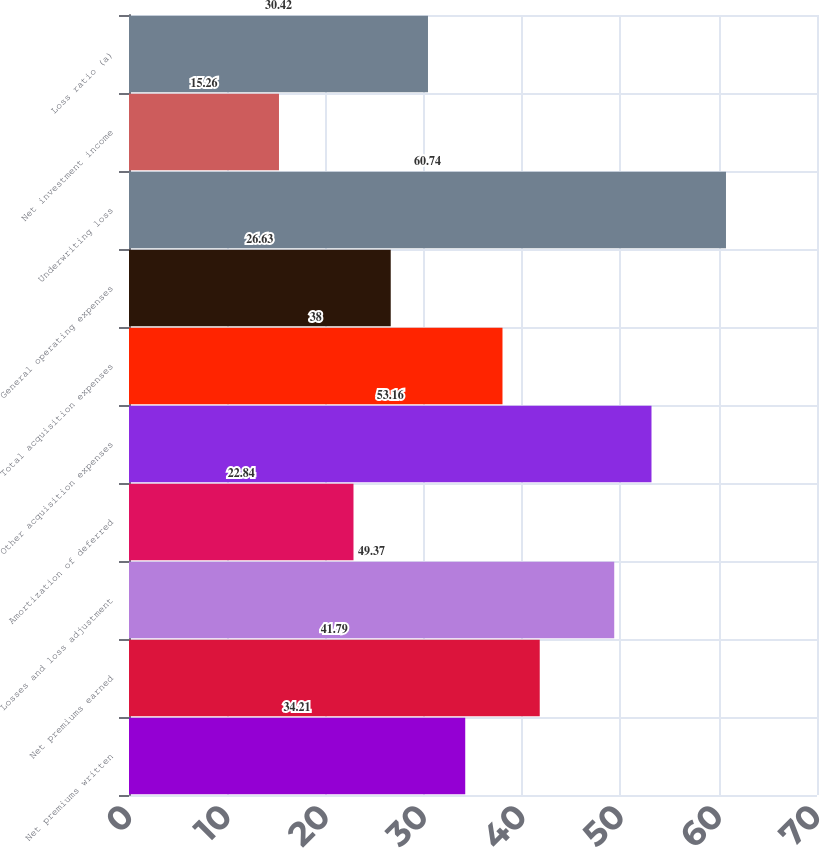Convert chart to OTSL. <chart><loc_0><loc_0><loc_500><loc_500><bar_chart><fcel>Net premiums written<fcel>Net premiums earned<fcel>Losses and loss adjustment<fcel>Amortization of deferred<fcel>Other acquisition expenses<fcel>Total acquisition expenses<fcel>General operating expenses<fcel>Underwriting loss<fcel>Net investment income<fcel>Loss ratio (a)<nl><fcel>34.21<fcel>41.79<fcel>49.37<fcel>22.84<fcel>53.16<fcel>38<fcel>26.63<fcel>60.74<fcel>15.26<fcel>30.42<nl></chart> 